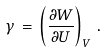<formula> <loc_0><loc_0><loc_500><loc_500>\gamma \, = \, \left ( \frac { \partial W } { \partial U } \right ) _ { V } \, .</formula> 